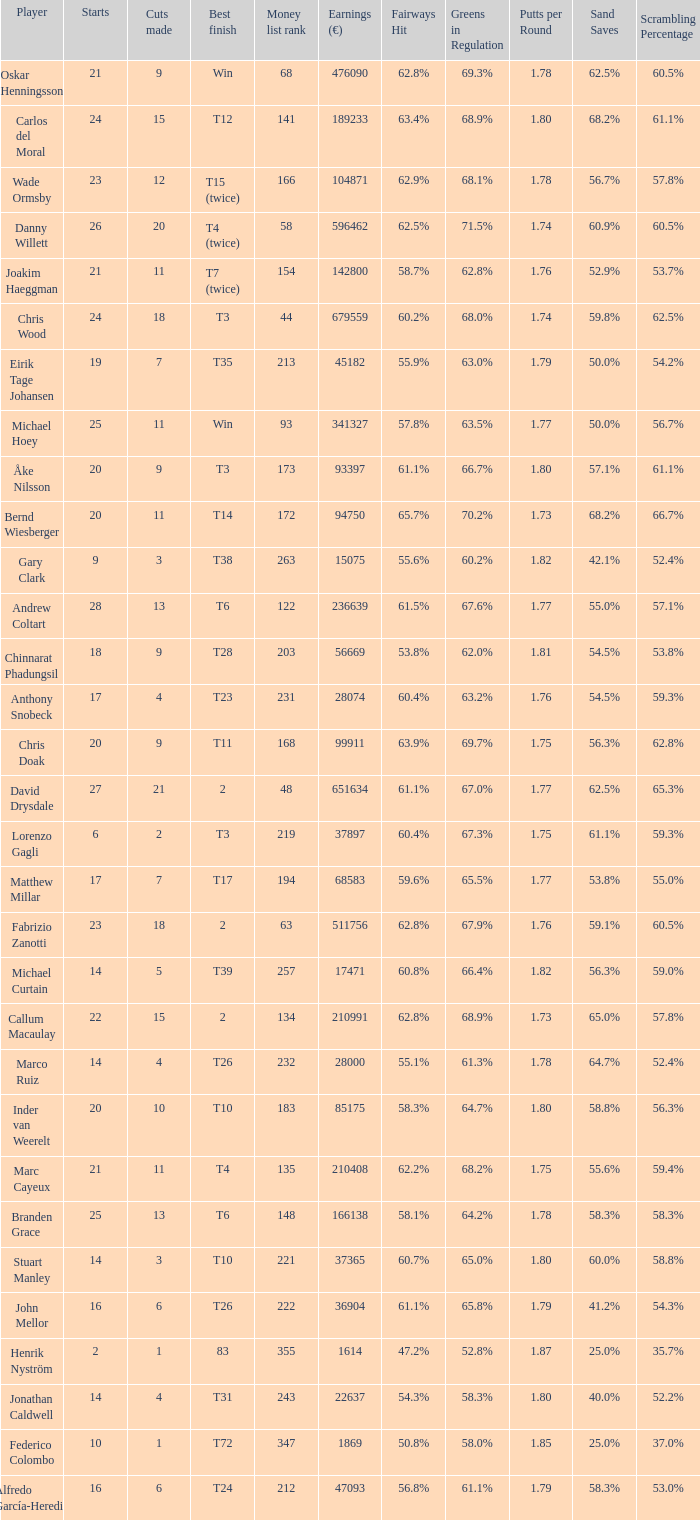How many cuts did the player who earned 210408 Euro make? 11.0. 